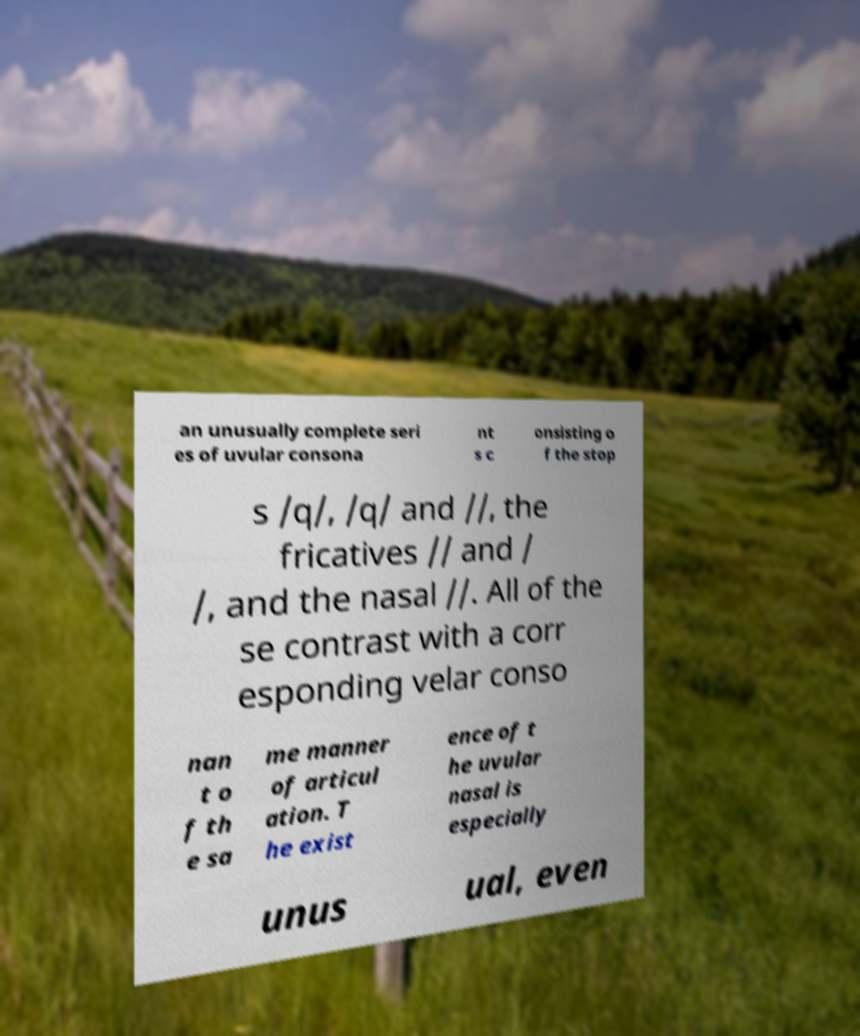Can you read and provide the text displayed in the image?This photo seems to have some interesting text. Can you extract and type it out for me? an unusually complete seri es of uvular consona nt s c onsisting o f the stop s /q/, /q/ and //, the fricatives // and / /, and the nasal //. All of the se contrast with a corr esponding velar conso nan t o f th e sa me manner of articul ation. T he exist ence of t he uvular nasal is especially unus ual, even 